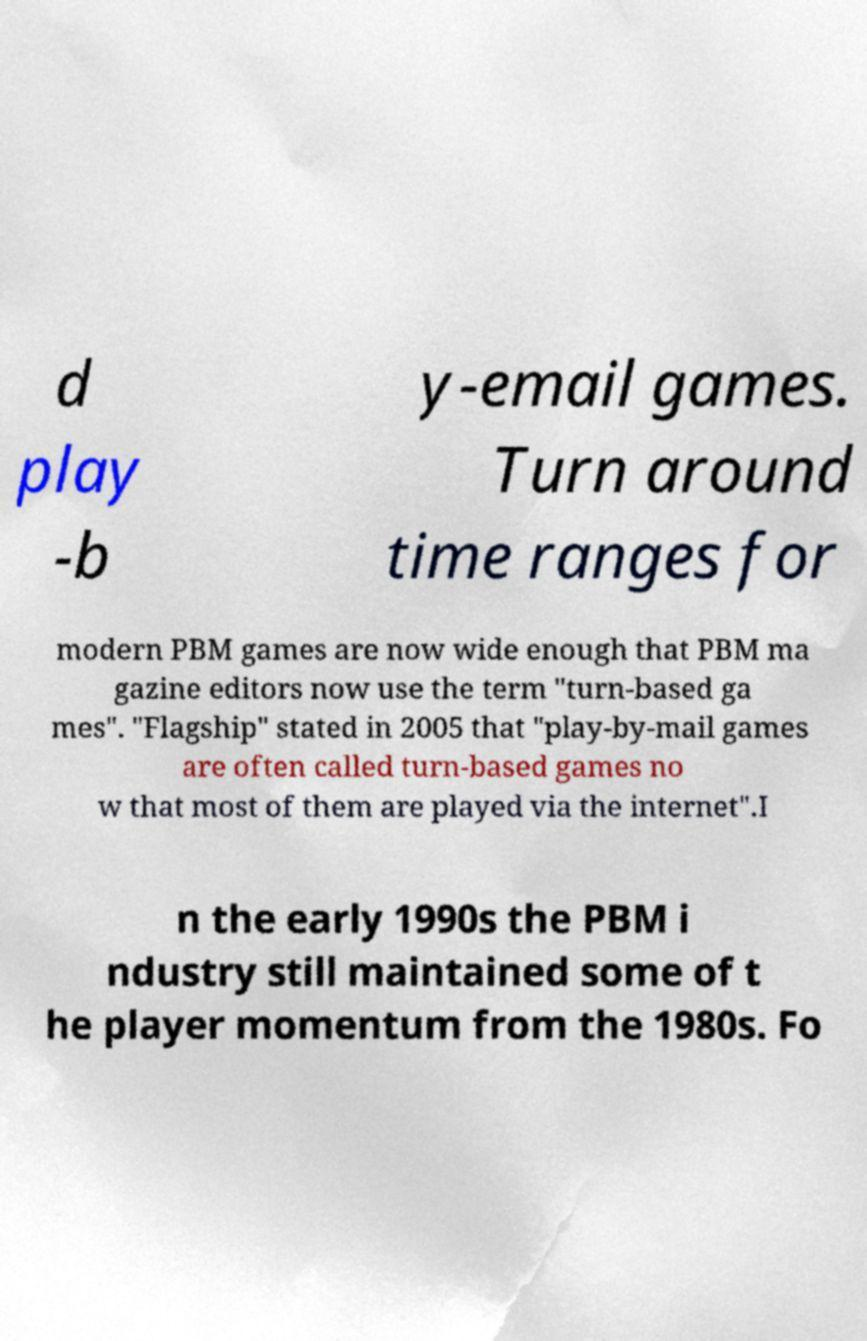Can you accurately transcribe the text from the provided image for me? d play -b y-email games. Turn around time ranges for modern PBM games are now wide enough that PBM ma gazine editors now use the term "turn-based ga mes". "Flagship" stated in 2005 that "play-by-mail games are often called turn-based games no w that most of them are played via the internet".I n the early 1990s the PBM i ndustry still maintained some of t he player momentum from the 1980s. Fo 